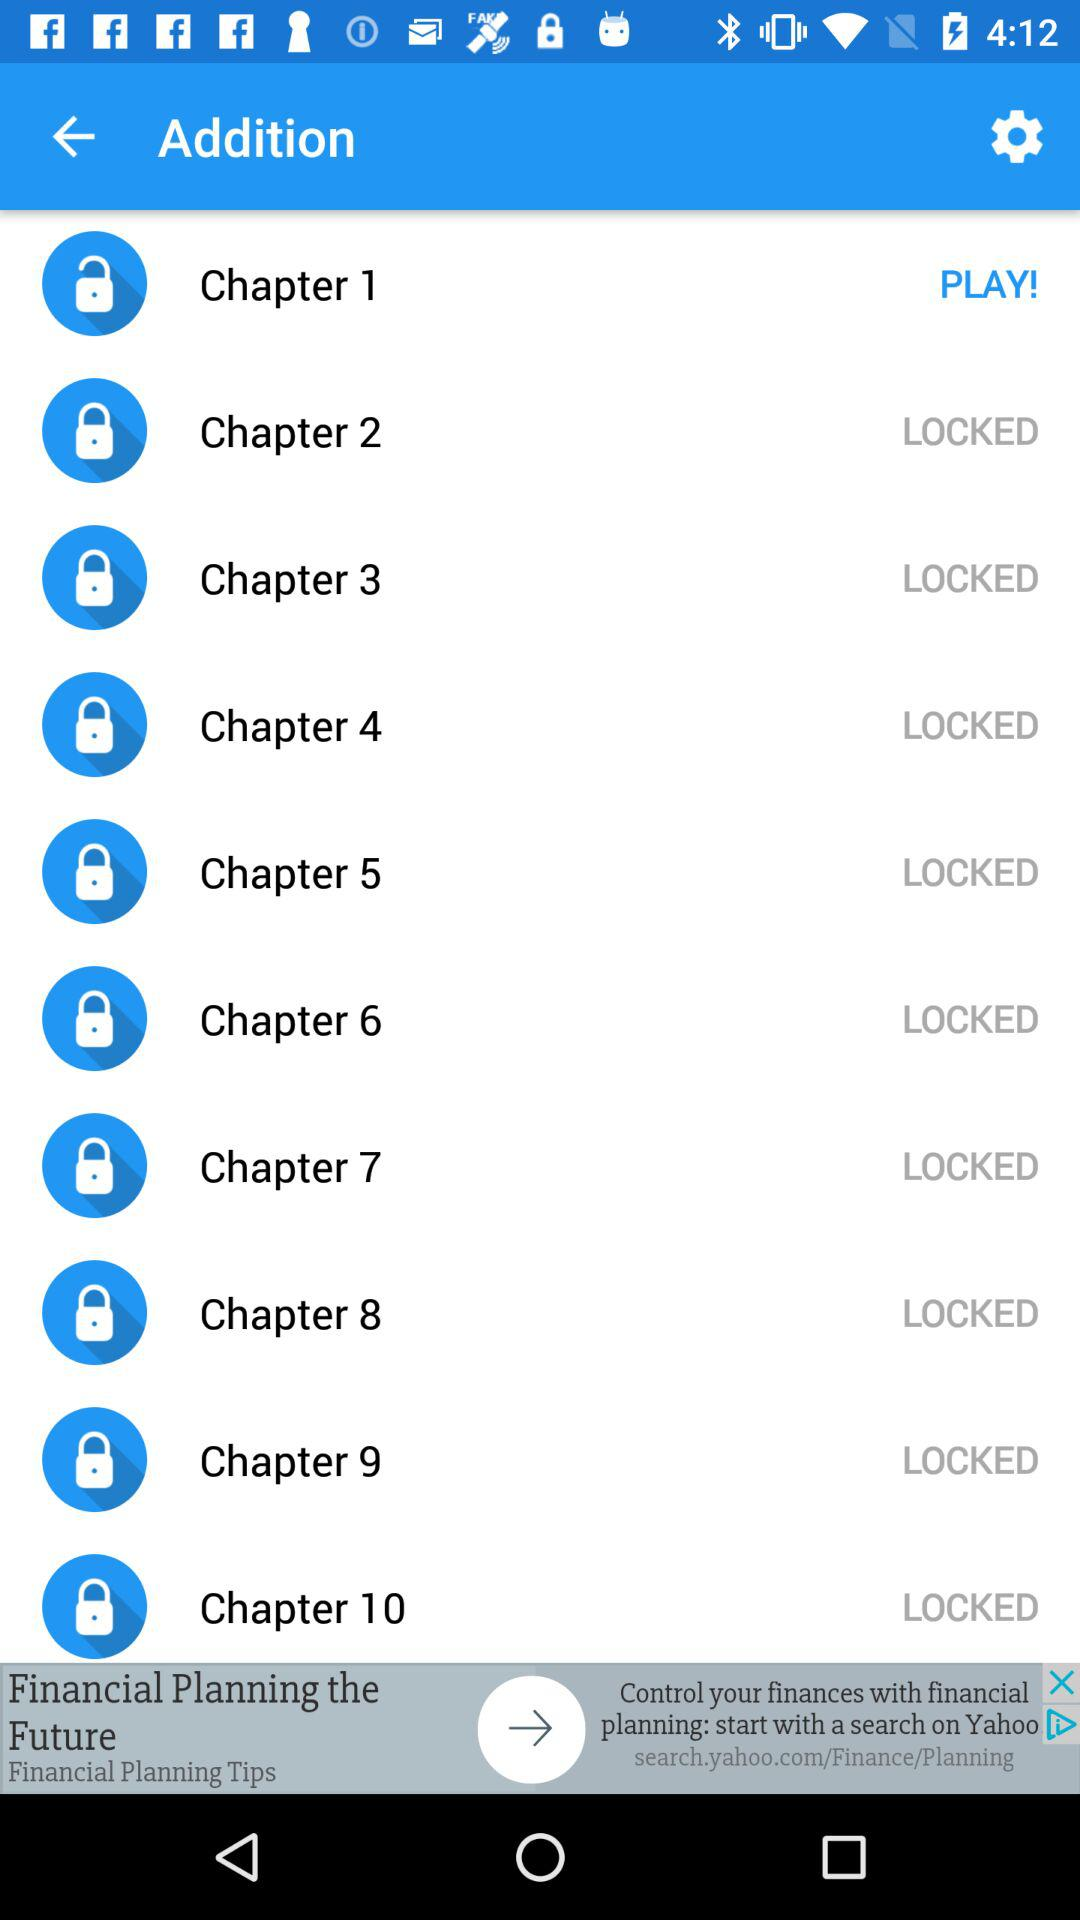Is "Chapter 2" locked or unlocked? "Chapter 2" is locked. 